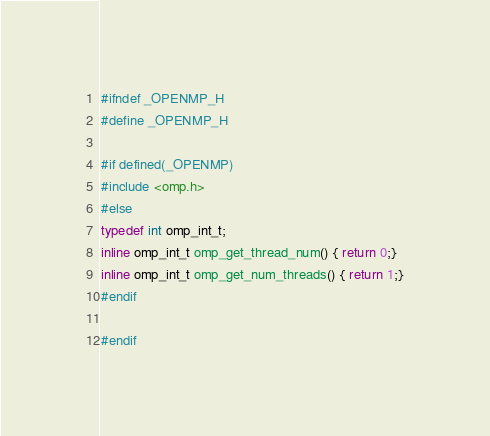Convert code to text. <code><loc_0><loc_0><loc_500><loc_500><_C_>#ifndef _OPENMP_H
#define _OPENMP_H

#if defined(_OPENMP)
#include <omp.h>
#else
typedef int omp_int_t;
inline omp_int_t omp_get_thread_num() { return 0;}
inline omp_int_t omp_get_num_threads() { return 1;}
#endif

#endif</code> 